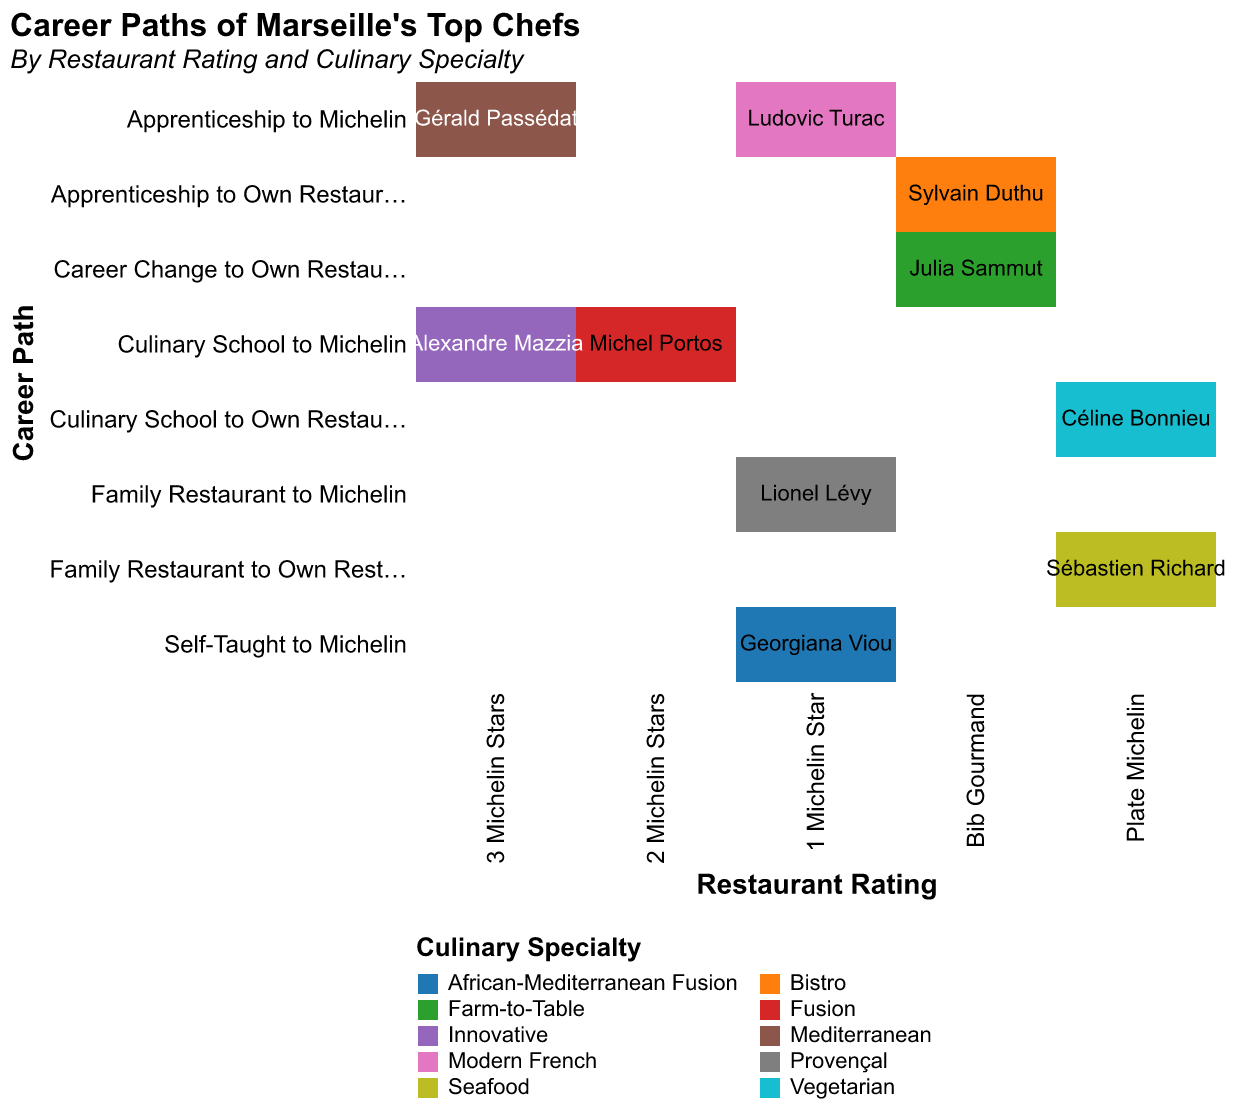What is the primary title of the mosaic plot? The main title of the mosaic plot is displayed at the top, giving an overview of the data represented in the chart
Answer: Career Paths of Marseille's Top Chefs Which chef has a career path of "Self-Taught to Michelin"? Find the section in the plot where the x-axis value is aligned to "Self-Taught to Michelin" and look for the name labeled in that area
Answer: Georgiana Viou How many chefs have received a "3 Michelin Stars" rating? Examine the number of data points (rectangles) under the "3 Michelin Stars" category on the x-axis
Answer: 2 Which culinary specialty appears the most under "Bib Gourmand" ratings? Identify the culinary specialties represented by color in the "Bib Gourmand" section and count their occurrences
Answer: Bistro Between "Plate Michelin" and "1 Michelin Star," which category has more career paths stemming from culinary schools? Compare the number of rectangles linked to "Culinary School to Michelin" under both "Plate Michelin" and "1 Michelin Star" ratings
Answer: They have equal number What is the predominant career path for chefs who received a "1 Michelin Star" rating? Look for the most frequent career path among the chefs listed under "1 Michelin Star" rating
Answer: Apprenticeship to Michelin Which culinary specialty is associated with the chef who has a "Fusion" specialty and a "2 Michelin Stars" rating? Locate the chef listed under both "Fusion" for culinary specialty and "2 Michelin Stars" for the rating and check their name
Answer: Michel Portos Who are the chefs with a "Bib Gourmand" rating, and what are their culinary specialties? Identify the rectangles under the "Bib Gourmand" section and note the chefs and their associated culinary specialties
Answer: Sylvain Duthu (Bistro), Julia Sammut (Farm-to-Table) Compare the number of chefs following an "Apprenticeship to Michelin" path with those on a "Culinary School to Own Restaurant" path. Count the number of rectangles in both "Apprenticeship to Michelin" and "Culinary School to Own Restaurant" categories and compare
Answer: Apprenticeship to Michelin has more Which career path has the most diverse range of culinary specialties across all chef ratings? Identify the career path (y-axis) associated with the highest variety of colors (culinary specialties) across all ratings
Answer: Culinary School to Michelin 